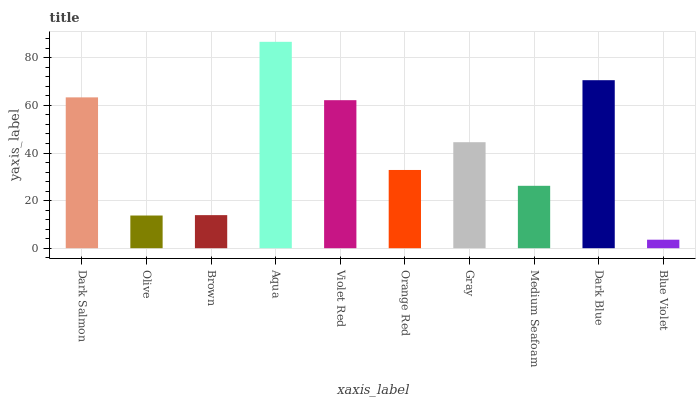Is Blue Violet the minimum?
Answer yes or no. Yes. Is Aqua the maximum?
Answer yes or no. Yes. Is Olive the minimum?
Answer yes or no. No. Is Olive the maximum?
Answer yes or no. No. Is Dark Salmon greater than Olive?
Answer yes or no. Yes. Is Olive less than Dark Salmon?
Answer yes or no. Yes. Is Olive greater than Dark Salmon?
Answer yes or no. No. Is Dark Salmon less than Olive?
Answer yes or no. No. Is Gray the high median?
Answer yes or no. Yes. Is Orange Red the low median?
Answer yes or no. Yes. Is Medium Seafoam the high median?
Answer yes or no. No. Is Dark Blue the low median?
Answer yes or no. No. 